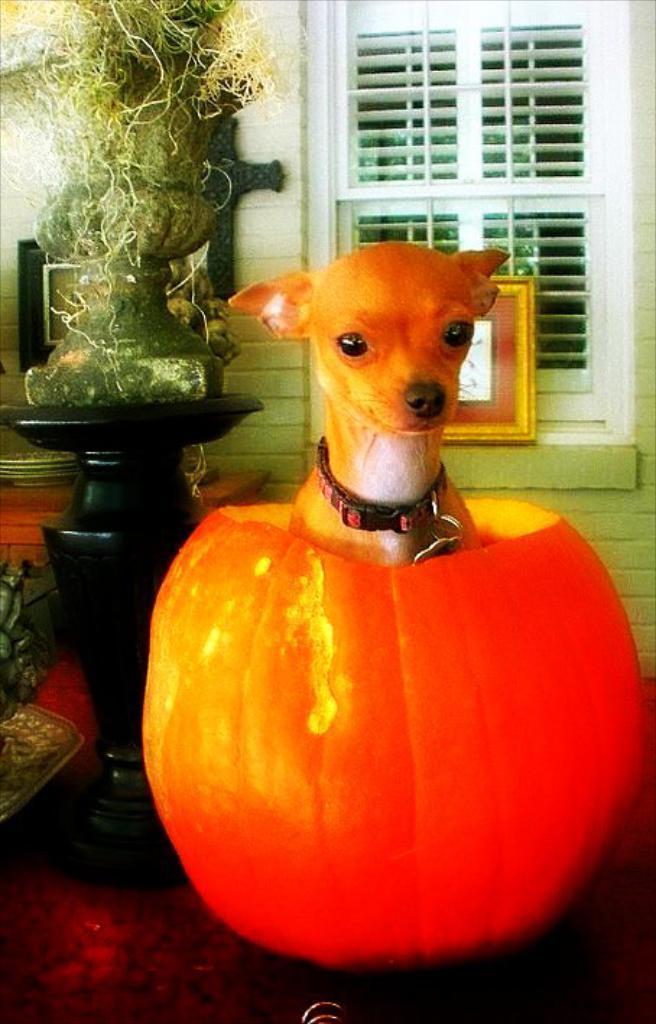Can you describe this image briefly? There is a dog in a red color object as we can see in the middle of this image. There is a wall in the background. There is a window at the top of this image and there is a flower vase on the left side of this image. 